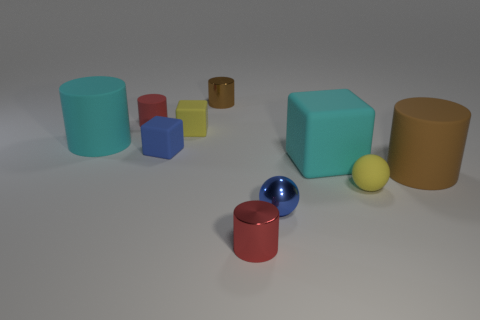Subtract all tiny yellow blocks. How many blocks are left? 2 Subtract all cyan cylinders. How many cylinders are left? 4 Subtract all balls. How many objects are left? 8 Add 9 red metallic things. How many red metallic things are left? 10 Add 10 large blue cubes. How many large blue cubes exist? 10 Subtract 0 brown balls. How many objects are left? 10 Subtract all brown cubes. Subtract all red cylinders. How many cubes are left? 3 Subtract all big red cylinders. Subtract all small blue spheres. How many objects are left? 9 